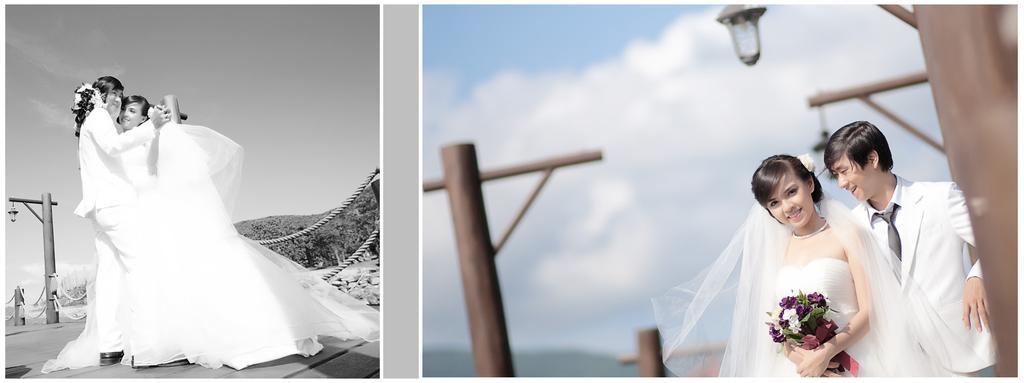Could you give a brief overview of what you see in this image? In this image we can see a collage image of a couple, lady is holding flowers, there are poles, lights, ropes, also we can see the mountains, and the sky. 